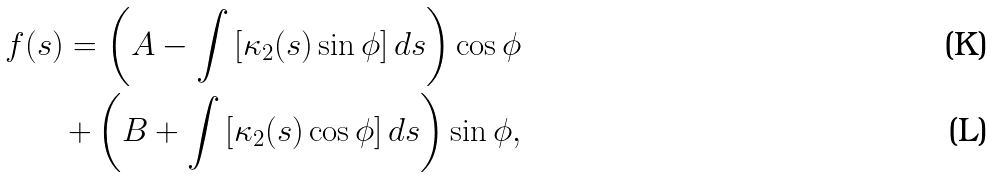<formula> <loc_0><loc_0><loc_500><loc_500>f ( s ) = \left ( A - \int \left [ \kappa _ { 2 } ( s ) \sin { \phi } \right ] d s \right ) \cos { \phi } \\ + \left ( B + \int \left [ \kappa _ { 2 } ( s ) \cos { \phi } \right ] d s \right ) \sin { \phi } ,</formula> 